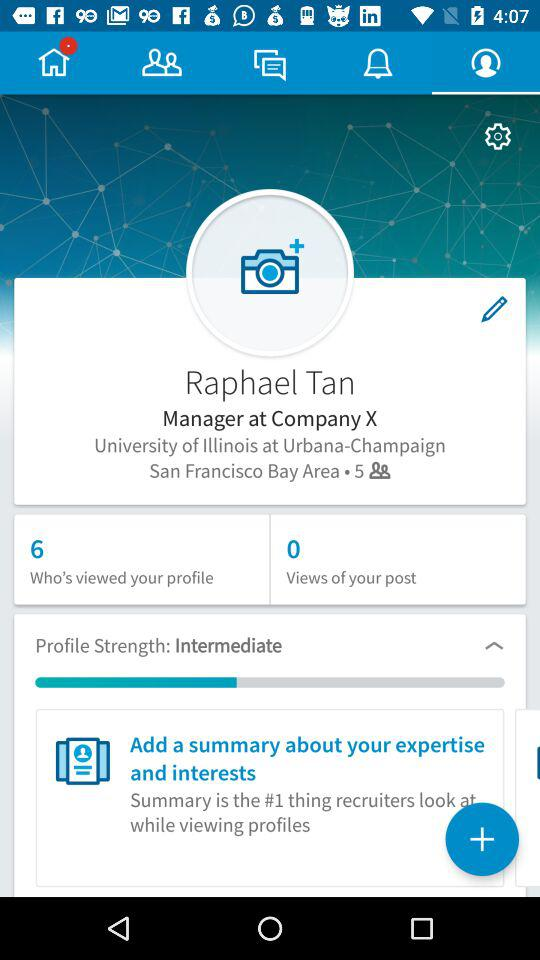How many more people have viewed my profile than views of my post?
Answer the question using a single word or phrase. 6 